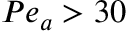<formula> <loc_0><loc_0><loc_500><loc_500>P e _ { a } > 3 0</formula> 